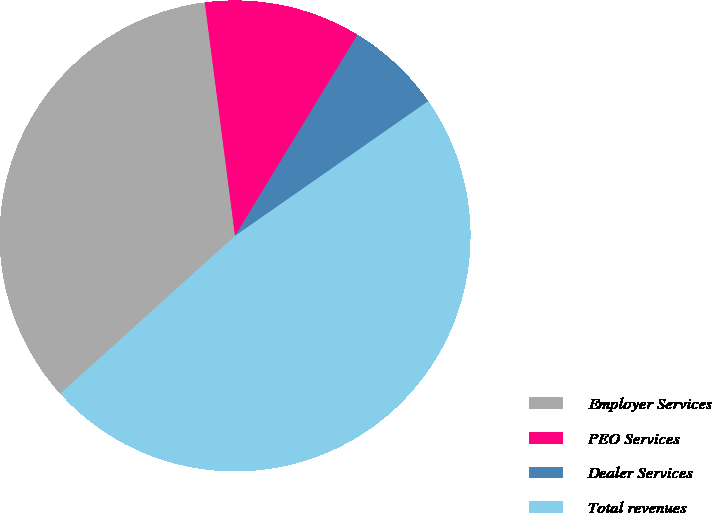Convert chart. <chart><loc_0><loc_0><loc_500><loc_500><pie_chart><fcel>Employer Services<fcel>PEO Services<fcel>Dealer Services<fcel>Total revenues<nl><fcel>34.64%<fcel>10.75%<fcel>6.61%<fcel>48.0%<nl></chart> 